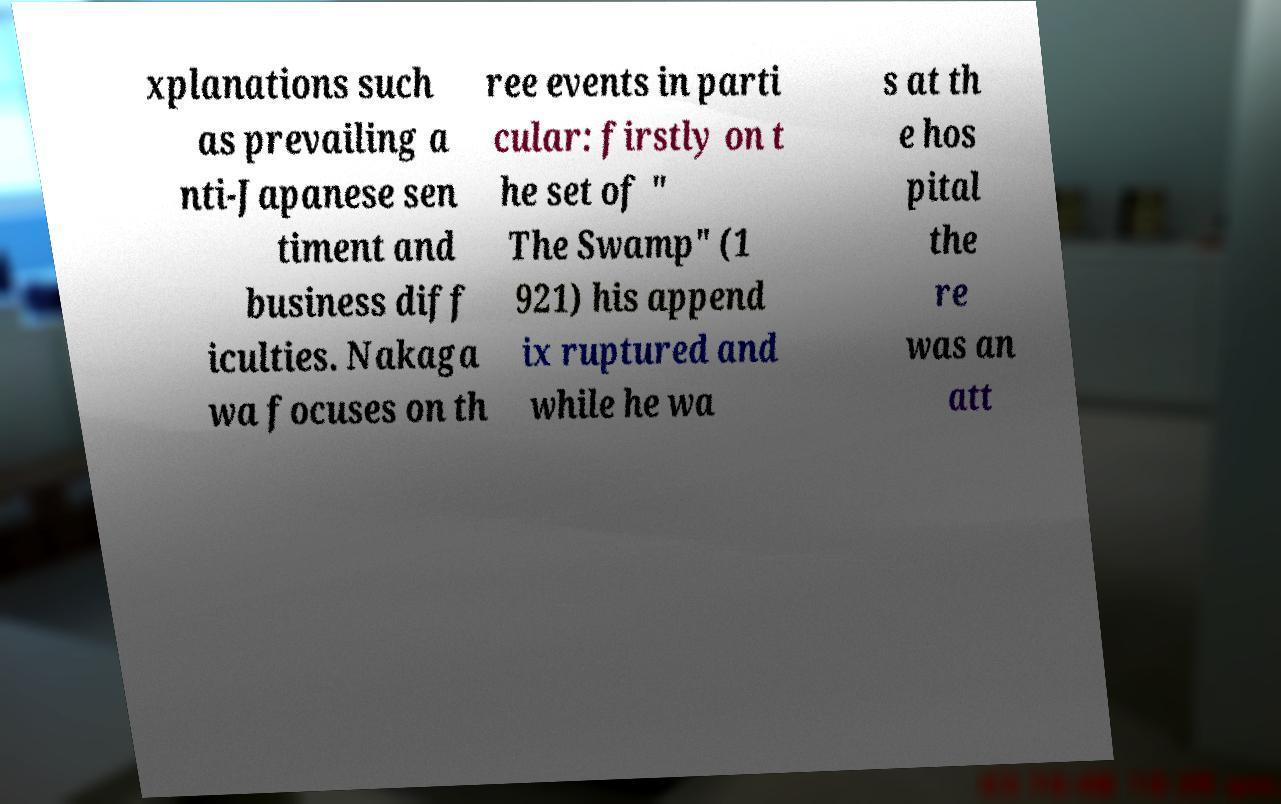There's text embedded in this image that I need extracted. Can you transcribe it verbatim? xplanations such as prevailing a nti-Japanese sen timent and business diff iculties. Nakaga wa focuses on th ree events in parti cular: firstly on t he set of " The Swamp" (1 921) his append ix ruptured and while he wa s at th e hos pital the re was an att 